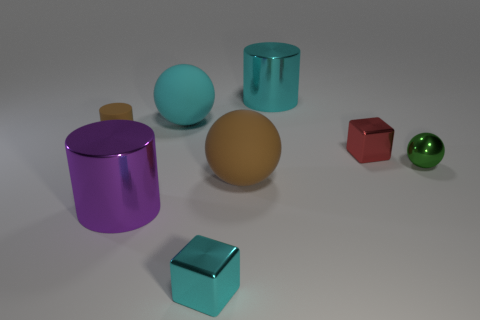Add 1 red cubes. How many objects exist? 9 Subtract all balls. How many objects are left? 5 Subtract all tiny cyan things. Subtract all cubes. How many objects are left? 5 Add 4 large spheres. How many large spheres are left? 6 Add 5 big blue metal cubes. How many big blue metal cubes exist? 5 Subtract 1 green balls. How many objects are left? 7 